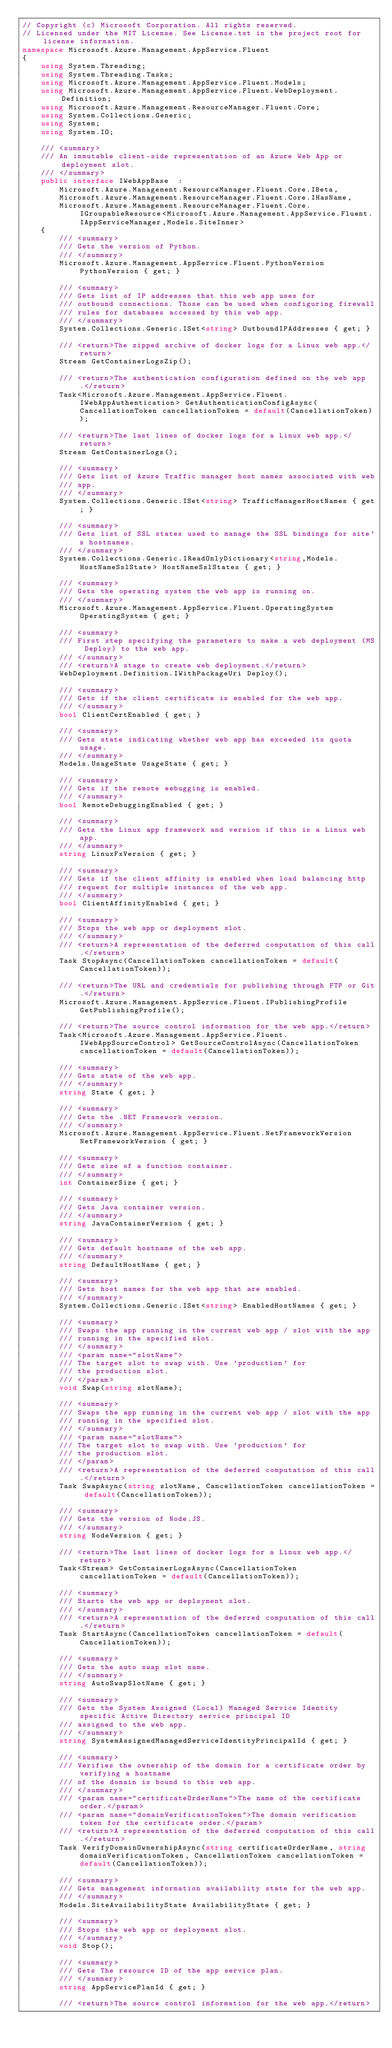Convert code to text. <code><loc_0><loc_0><loc_500><loc_500><_C#_>// Copyright (c) Microsoft Corporation. All rights reserved.
// Licensed under the MIT License. See License.txt in the project root for license information.
namespace Microsoft.Azure.Management.AppService.Fluent
{
    using System.Threading;
    using System.Threading.Tasks;
    using Microsoft.Azure.Management.AppService.Fluent.Models;
    using Microsoft.Azure.Management.AppService.Fluent.WebDeployment.Definition;
    using Microsoft.Azure.Management.ResourceManager.Fluent.Core;
    using System.Collections.Generic;
    using System;
    using System.IO;

    /// <summary>
    /// An immutable client-side representation of an Azure Web App or deployment slot.
    /// </summary>
    public interface IWebAppBase  :
        Microsoft.Azure.Management.ResourceManager.Fluent.Core.IBeta,
        Microsoft.Azure.Management.ResourceManager.Fluent.Core.IHasName,
        Microsoft.Azure.Management.ResourceManager.Fluent.Core.IGroupableResource<Microsoft.Azure.Management.AppService.Fluent.IAppServiceManager,Models.SiteInner>
    {
        /// <summary>
        /// Gets the version of Python.
        /// </summary>
        Microsoft.Azure.Management.AppService.Fluent.PythonVersion PythonVersion { get; }

        /// <summary>
        /// Gets list of IP addresses that this web app uses for
        /// outbound connections. Those can be used when configuring firewall
        /// rules for databases accessed by this web app.
        /// </summary>
        System.Collections.Generic.ISet<string> OutboundIPAddresses { get; }

        /// <return>The zipped archive of docker logs for a Linux web app.</return>
        Stream GetContainerLogsZip();

        /// <return>The authentication configuration defined on the web app.</return>
        Task<Microsoft.Azure.Management.AppService.Fluent.IWebAppAuthentication> GetAuthenticationConfigAsync(CancellationToken cancellationToken = default(CancellationToken));

        /// <return>The last lines of docker logs for a Linux web app.</return>
        Stream GetContainerLogs();

        /// <summary>
        /// Gets list of Azure Traffic manager host names associated with web
        /// app.
        /// </summary>
        System.Collections.Generic.ISet<string> TrafficManagerHostNames { get; }

        /// <summary>
        /// Gets list of SSL states used to manage the SSL bindings for site's hostnames.
        /// </summary>
        System.Collections.Generic.IReadOnlyDictionary<string,Models.HostNameSslState> HostNameSslStates { get; }

        /// <summary>
        /// Gets the operating system the web app is running on.
        /// </summary>
        Microsoft.Azure.Management.AppService.Fluent.OperatingSystem OperatingSystem { get; }

        /// <summary>
        /// First step specifying the parameters to make a web deployment (MS Deploy) to the web app.
        /// </summary>
        /// <return>A stage to create web deployment.</return>
        WebDeployment.Definition.IWithPackageUri Deploy();

        /// <summary>
        /// Gets if the client certificate is enabled for the web app.
        /// </summary>
        bool ClientCertEnabled { get; }

        /// <summary>
        /// Gets state indicating whether web app has exceeded its quota usage.
        /// </summary>
        Models.UsageState UsageState { get; }

        /// <summary>
        /// Gets if the remote eebugging is enabled.
        /// </summary>
        bool RemoteDebuggingEnabled { get; }

        /// <summary>
        /// Gets the Linux app framework and version if this is a Linux web app.
        /// </summary>
        string LinuxFxVersion { get; }

        /// <summary>
        /// Gets if the client affinity is enabled when load balancing http
        /// request for multiple instances of the web app.
        /// </summary>
        bool ClientAffinityEnabled { get; }

        /// <summary>
        /// Stops the web app or deployment slot.
        /// </summary>
        /// <return>A representation of the deferred computation of this call.</return>
        Task StopAsync(CancellationToken cancellationToken = default(CancellationToken));

        /// <return>The URL and credentials for publishing through FTP or Git.</return>
        Microsoft.Azure.Management.AppService.Fluent.IPublishingProfile GetPublishingProfile();

        /// <return>The source control information for the web app.</return>
        Task<Microsoft.Azure.Management.AppService.Fluent.IWebAppSourceControl> GetSourceControlAsync(CancellationToken cancellationToken = default(CancellationToken));

        /// <summary>
        /// Gets state of the web app.
        /// </summary>
        string State { get; }

        /// <summary>
        /// Gets the .NET Framework version.
        /// </summary>
        Microsoft.Azure.Management.AppService.Fluent.NetFrameworkVersion NetFrameworkVersion { get; }

        /// <summary>
        /// Gets size of a function container.
        /// </summary>
        int ContainerSize { get; }

        /// <summary>
        /// Gets Java container version.
        /// </summary>
        string JavaContainerVersion { get; }

        /// <summary>
        /// Gets default hostname of the web app.
        /// </summary>
        string DefaultHostName { get; }

        /// <summary>
        /// Gets host names for the web app that are enabled.
        /// </summary>
        System.Collections.Generic.ISet<string> EnabledHostNames { get; }

        /// <summary>
        /// Swaps the app running in the current web app / slot with the app
        /// running in the specified slot.
        /// </summary>
        /// <param name="slotName">
        /// The target slot to swap with. Use 'production' for
        /// the production slot.
        /// </param>
        void Swap(string slotName);

        /// <summary>
        /// Swaps the app running in the current web app / slot with the app
        /// running in the specified slot.
        /// </summary>
        /// <param name="slotName">
        /// The target slot to swap with. Use 'production' for
        /// the production slot.
        /// </param>
        /// <return>A representation of the deferred computation of this call.</return>
        Task SwapAsync(string slotName, CancellationToken cancellationToken = default(CancellationToken));

        /// <summary>
        /// Gets the version of Node.JS.
        /// </summary>
        string NodeVersion { get; }

        /// <return>The last lines of docker logs for a Linux web app.</return>
        Task<Stream> GetContainerLogsAsync(CancellationToken cancellationToken = default(CancellationToken));

        /// <summary>
        /// Starts the web app or deployment slot.
        /// </summary>
        /// <return>A representation of the deferred computation of this call.</return>
        Task StartAsync(CancellationToken cancellationToken = default(CancellationToken));

        /// <summary>
        /// Gets the auto swap slot name.
        /// </summary>
        string AutoSwapSlotName { get; }

        /// <summary>
        /// Gets the System Assigned (Local) Managed Service Identity specific Active Directory service principal ID
        /// assigned to the web app.
        /// </summary>
        string SystemAssignedManagedServiceIdentityPrincipalId { get; }

        /// <summary>
        /// Verifies the ownership of the domain for a certificate order by verifying a hostname
        /// of the domain is bound to this web app.
        /// </summary>
        /// <param name="certificateOrderName">The name of the certificate order.</param>
        /// <param name="domainVerificationToken">The domain verification token for the certificate order.</param>
        /// <return>A representation of the deferred computation of this call.</return>
        Task VerifyDomainOwnershipAsync(string certificateOrderName, string domainVerificationToken, CancellationToken cancellationToken = default(CancellationToken));

        /// <summary>
        /// Gets management information availability state for the web app.
        /// </summary>
        Models.SiteAvailabilityState AvailabilityState { get; }

        /// <summary>
        /// Stops the web app or deployment slot.
        /// </summary>
        void Stop();

        /// <summary>
        /// Gets The resource ID of the app service plan.
        /// </summary>
        string AppServicePlanId { get; }

        /// <return>The source control information for the web app.</return></code> 